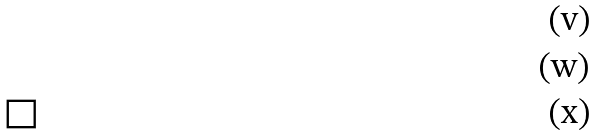<formula> <loc_0><loc_0><loc_500><loc_500>& \\ & \\ & \Box</formula> 